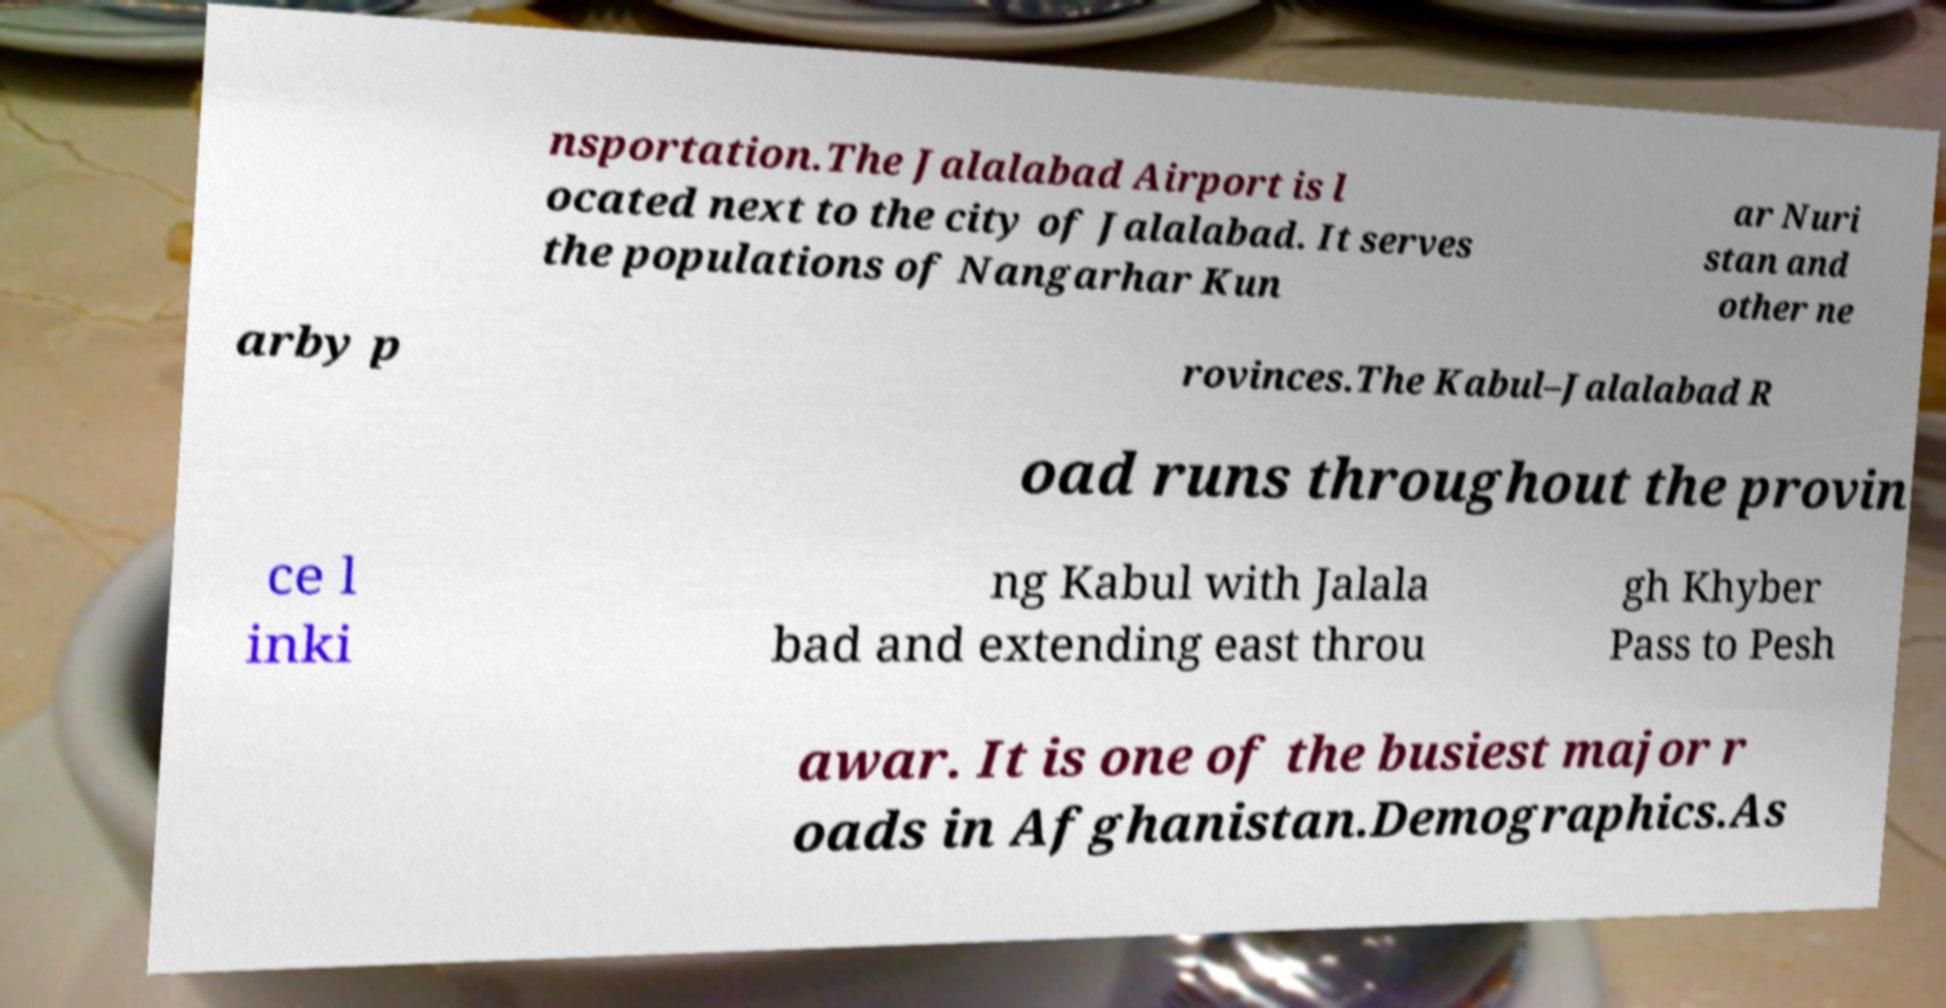Could you extract and type out the text from this image? nsportation.The Jalalabad Airport is l ocated next to the city of Jalalabad. It serves the populations of Nangarhar Kun ar Nuri stan and other ne arby p rovinces.The Kabul–Jalalabad R oad runs throughout the provin ce l inki ng Kabul with Jalala bad and extending east throu gh Khyber Pass to Pesh awar. It is one of the busiest major r oads in Afghanistan.Demographics.As 